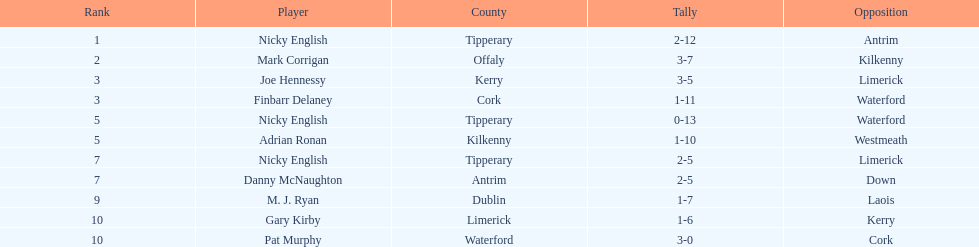What was the combined total of nicky english and mark corrigan? 34. 